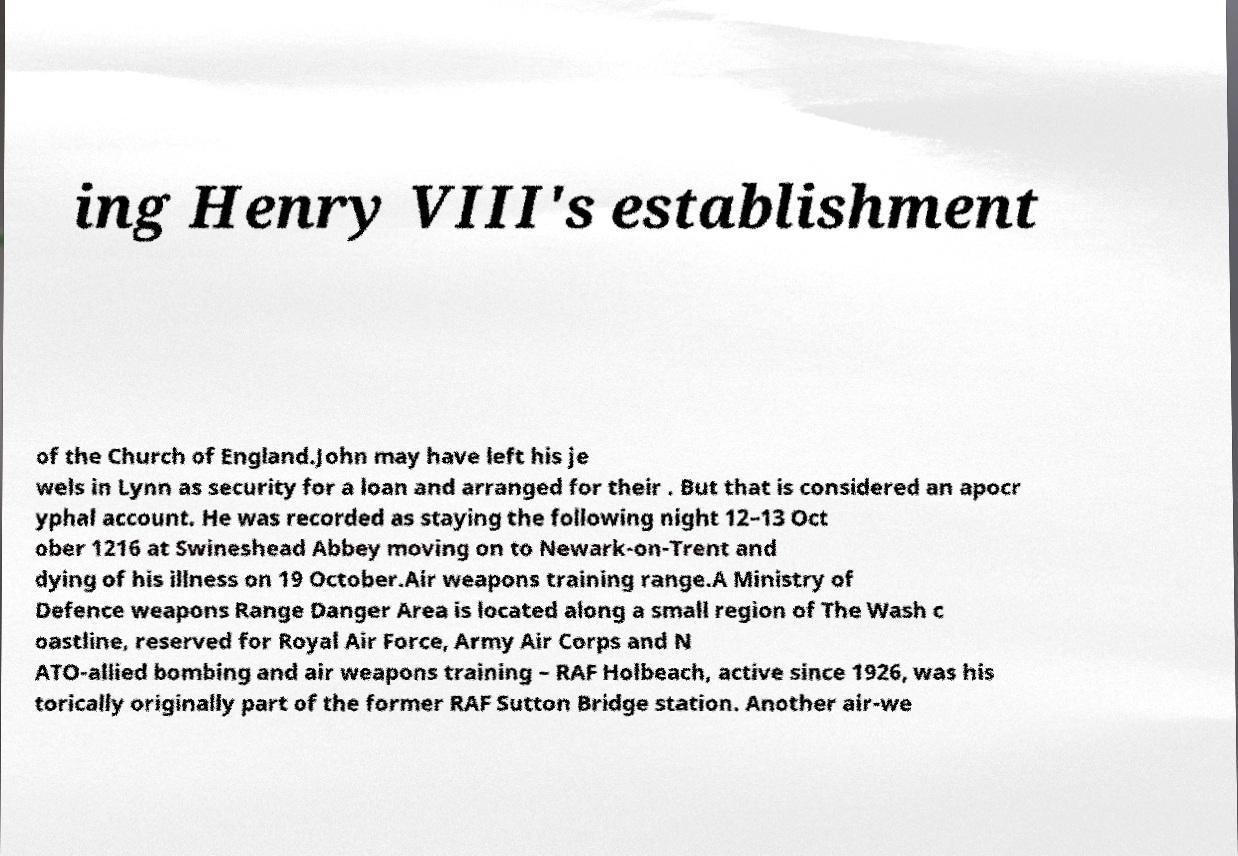Could you extract and type out the text from this image? ing Henry VIII's establishment of the Church of England.John may have left his je wels in Lynn as security for a loan and arranged for their . But that is considered an apocr yphal account. He was recorded as staying the following night 12–13 Oct ober 1216 at Swineshead Abbey moving on to Newark-on-Trent and dying of his illness on 19 October.Air weapons training range.A Ministry of Defence weapons Range Danger Area is located along a small region of The Wash c oastline, reserved for Royal Air Force, Army Air Corps and N ATO-allied bombing and air weapons training – RAF Holbeach, active since 1926, was his torically originally part of the former RAF Sutton Bridge station. Another air-we 